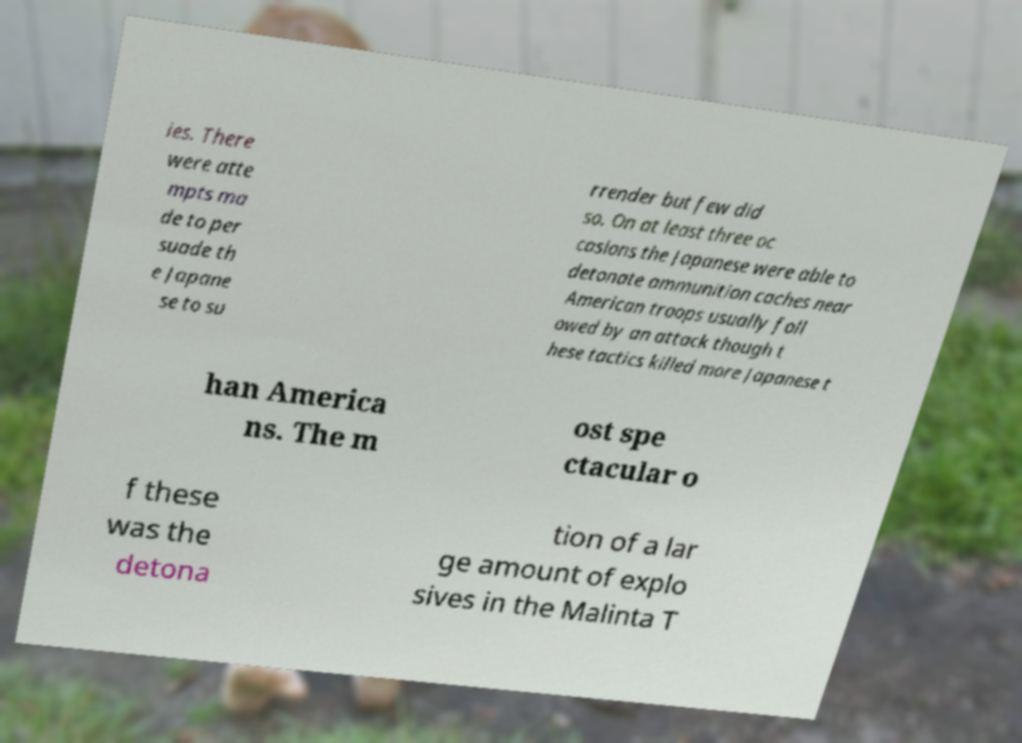I need the written content from this picture converted into text. Can you do that? ies. There were atte mpts ma de to per suade th e Japane se to su rrender but few did so. On at least three oc casions the Japanese were able to detonate ammunition caches near American troops usually foll owed by an attack though t hese tactics killed more Japanese t han America ns. The m ost spe ctacular o f these was the detona tion of a lar ge amount of explo sives in the Malinta T 